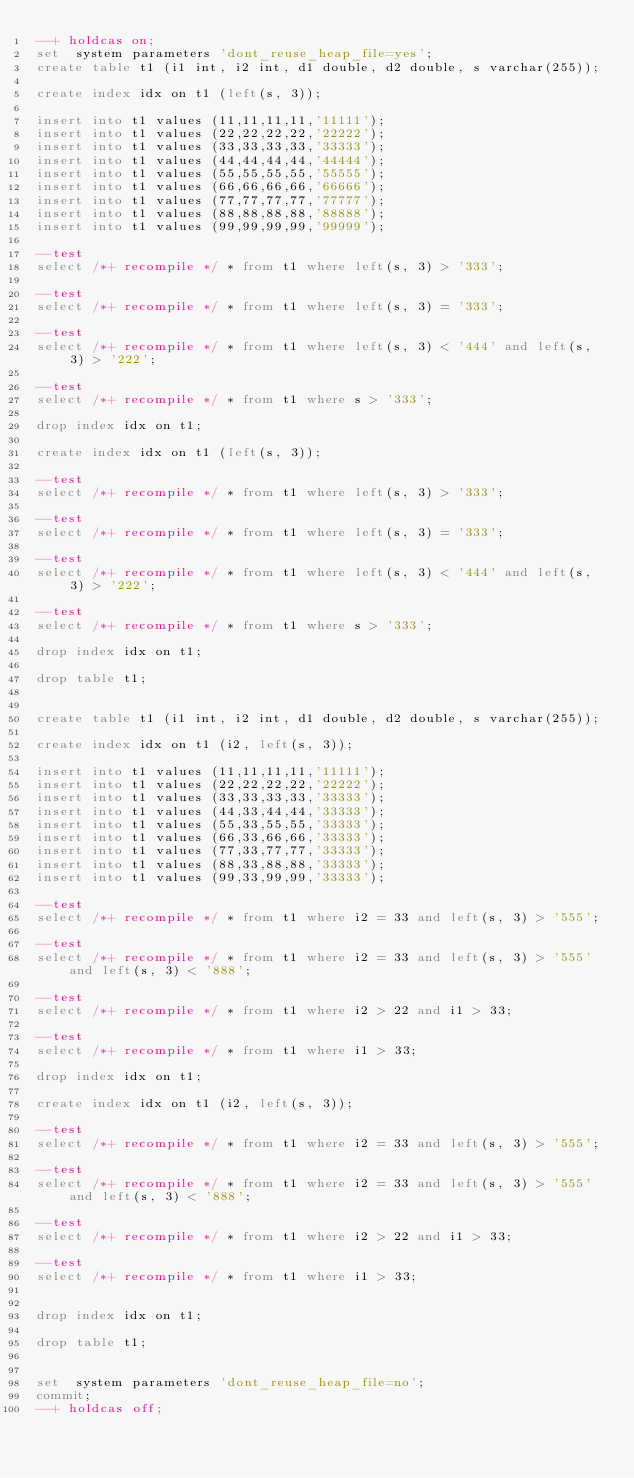Convert code to text. <code><loc_0><loc_0><loc_500><loc_500><_SQL_>--+ holdcas on;
set  system parameters 'dont_reuse_heap_file=yes';
create table t1 (i1 int, i2 int, d1 double, d2 double, s varchar(255));

create index idx on t1 (left(s, 3));

insert into t1 values (11,11,11,11,'11111');
insert into t1 values (22,22,22,22,'22222');
insert into t1 values (33,33,33,33,'33333');
insert into t1 values (44,44,44,44,'44444');
insert into t1 values (55,55,55,55,'55555');
insert into t1 values (66,66,66,66,'66666');
insert into t1 values (77,77,77,77,'77777');
insert into t1 values (88,88,88,88,'88888');
insert into t1 values (99,99,99,99,'99999');

--test
select /*+ recompile */ * from t1 where left(s, 3) > '333';

--test
select /*+ recompile */ * from t1 where left(s, 3) = '333';

--test
select /*+ recompile */ * from t1 where left(s, 3) < '444' and left(s, 3) > '222';

--test
select /*+ recompile */ * from t1 where s > '333';

drop index idx on t1;

create index idx on t1 (left(s, 3));

--test
select /*+ recompile */ * from t1 where left(s, 3) > '333';

--test
select /*+ recompile */ * from t1 where left(s, 3) = '333';

--test
select /*+ recompile */ * from t1 where left(s, 3) < '444' and left(s, 3) > '222';

--test
select /*+ recompile */ * from t1 where s > '333';

drop index idx on t1;

drop table t1;


create table t1 (i1 int, i2 int, d1 double, d2 double, s varchar(255));

create index idx on t1 (i2, left(s, 3));

insert into t1 values (11,11,11,11,'11111');
insert into t1 values (22,22,22,22,'22222');
insert into t1 values (33,33,33,33,'33333');
insert into t1 values (44,33,44,44,'33333');
insert into t1 values (55,33,55,55,'33333');
insert into t1 values (66,33,66,66,'33333');
insert into t1 values (77,33,77,77,'33333');
insert into t1 values (88,33,88,88,'33333');
insert into t1 values (99,33,99,99,'33333');

--test
select /*+ recompile */ * from t1 where i2 = 33 and left(s, 3) > '555';

--test
select /*+ recompile */ * from t1 where i2 = 33 and left(s, 3) > '555' and left(s, 3) < '888';

--test
select /*+ recompile */ * from t1 where i2 > 22 and i1 > 33;

--test
select /*+ recompile */ * from t1 where i1 > 33;

drop index idx on t1;

create index idx on t1 (i2, left(s, 3));

--test
select /*+ recompile */ * from t1 where i2 = 33 and left(s, 3) > '555';

--test
select /*+ recompile */ * from t1 where i2 = 33 and left(s, 3) > '555' and left(s, 3) < '888';

--test
select /*+ recompile */ * from t1 where i2 > 22 and i1 > 33;

--test
select /*+ recompile */ * from t1 where i1 > 33;


drop index idx on t1;

drop table t1;


set  system parameters 'dont_reuse_heap_file=no';
commit;
--+ holdcas off;
</code> 